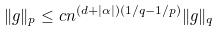<formula> <loc_0><loc_0><loc_500><loc_500>\| g \| _ { p } \leq c n ^ { ( d + | \alpha | ) ( 1 / q - 1 / p ) } \| g \| _ { q }</formula> 